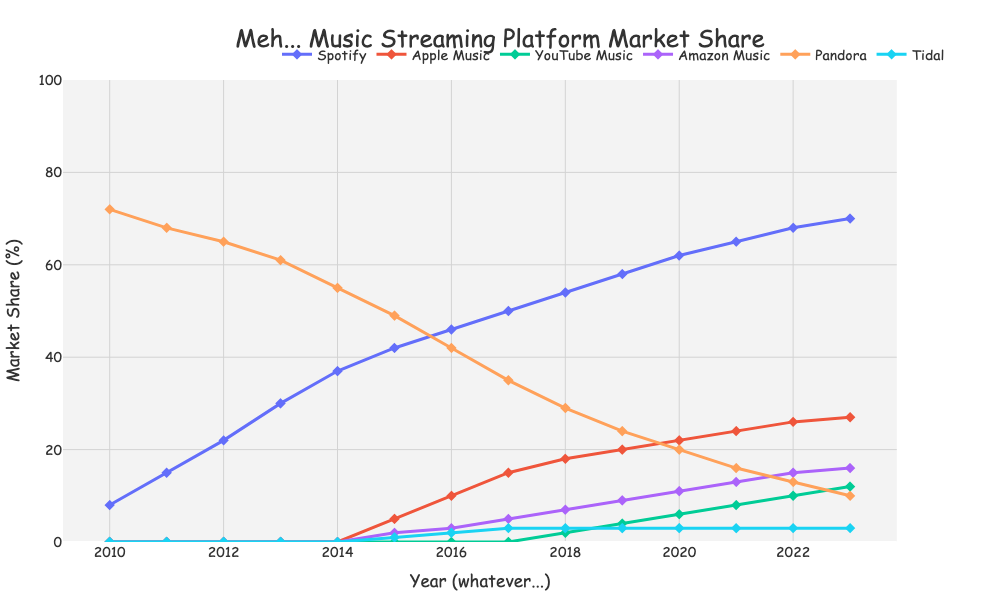Which platform had the highest market share in 2010? By looking at the lines and markers on the graph for 2010, we can see that Pandora had the highest market share.
Answer: Pandora In which year did Apple Music first appear in the market share data? The line for Apple Music begins in the year 2015.
Answer: 2015 Compare Spotify's market share trends from 2012 to 2015 with Pandora's market share during the same period. From 2012 to 2015, Spotify's market share increased from 22% to 42%, while Pandora's market share decreased from 65% to 49%.
Answer: Spotify increased, Pandora decreased How many platforms had a market share above 10% in 2023? By examining the market share values for each platform in 2023, we see that Spotify, Apple Music, YouTube Music, and Amazon Music had shares above 10%.
Answer: 4 What was the difference in market share between Spotify and Apple Music in 2023? In 2023, Spotify's market share was 70% and Apple Music's was 27%. The difference is 70% - 27% = 43%.
Answer: 43% What’s the total market share of YouTube Music and Tidal combined in 2018? In 2018, YouTube Music had a 2% market share and Tidal had a 3% market share, so the total is 2% + 3% = 5%.
Answer: 5% Which platform showed the largest increase in market share from 2010 to 2023? By looking at the entire period from 2010 to 2023, Spotify had the largest increase moving from 8% to 70%.
Answer: Spotify In what year did Amazon Music's market share surpass Pandora's market share? By observing the graph, we see that Amazon Music surpassed Pandora in market share in 2022.
Answer: 2022 What’s the average market share of Tidal from 2010 to 2023? Tidal has market share data from 2015 onwards with values 1%, 2%, 3%, 3%, 3%, 3%, 3%, and 3%, adding up to 18%. There are 8 years, so the average is 18% / 8 = 2.25%.
Answer: 2.25% Which year had the highest combined market share of Spotify and Amazon Music? By calculating the sum of Spotify and Amazon Music for each year, 2023 has the highest combined market share: 70% (Spotify) + 16% (Amazon Music) = 86%.
Answer: 2023 